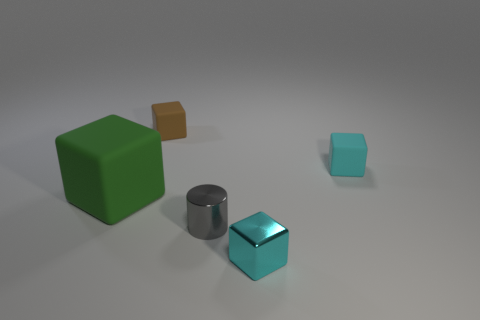There is a cyan object that is behind the green object; is its shape the same as the cyan thing in front of the cyan matte object?
Your answer should be very brief. Yes. What number of other things are there of the same color as the metal block?
Provide a succinct answer. 1. Do the cyan thing behind the green block and the gray cylinder have the same size?
Provide a short and direct response. Yes. Do the tiny cyan object that is in front of the green block and the thing that is behind the cyan rubber object have the same material?
Keep it short and to the point. No. Is there a purple ball that has the same size as the gray shiny cylinder?
Ensure brevity in your answer.  No. There is a object that is behind the rubber cube on the right side of the small cyan object that is in front of the large block; what is its shape?
Give a very brief answer. Cube. Is the number of small brown things that are in front of the large cube greater than the number of rubber blocks?
Ensure brevity in your answer.  No. Are there any gray metal objects that have the same shape as the green object?
Offer a very short reply. No. Does the small cylinder have the same material as the cyan cube behind the shiny cylinder?
Your answer should be very brief. No. The tiny cylinder has what color?
Ensure brevity in your answer.  Gray. 